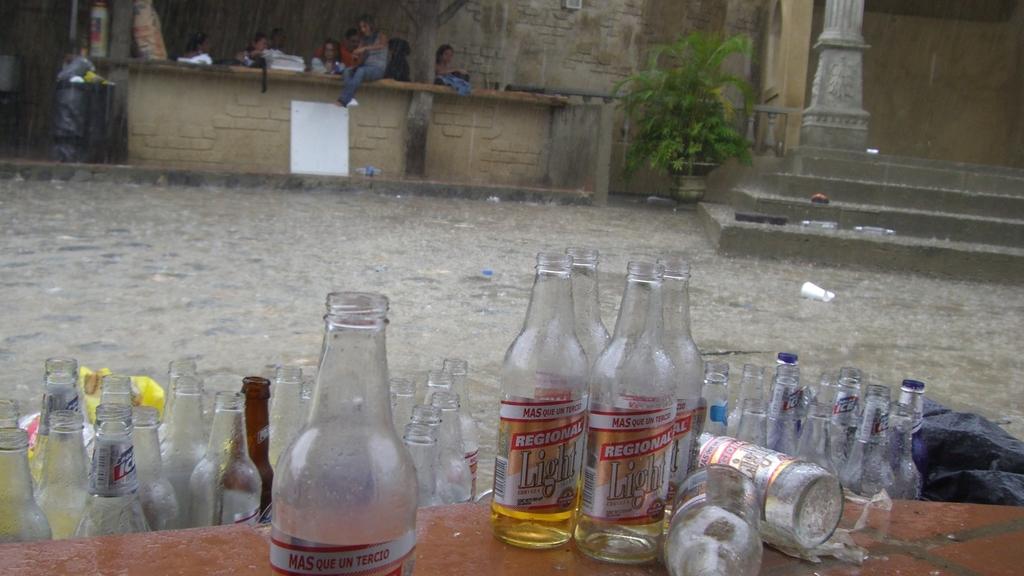What are those empty bottles?
Provide a short and direct response. Regional light. Is that light beer?
Offer a terse response. Yes. 